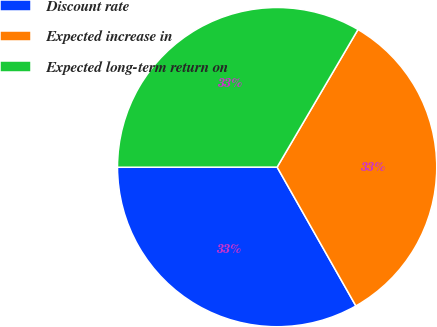Convert chart to OTSL. <chart><loc_0><loc_0><loc_500><loc_500><pie_chart><fcel>Discount rate<fcel>Expected increase in<fcel>Expected long-term return on<nl><fcel>33.2%<fcel>33.33%<fcel>33.47%<nl></chart> 